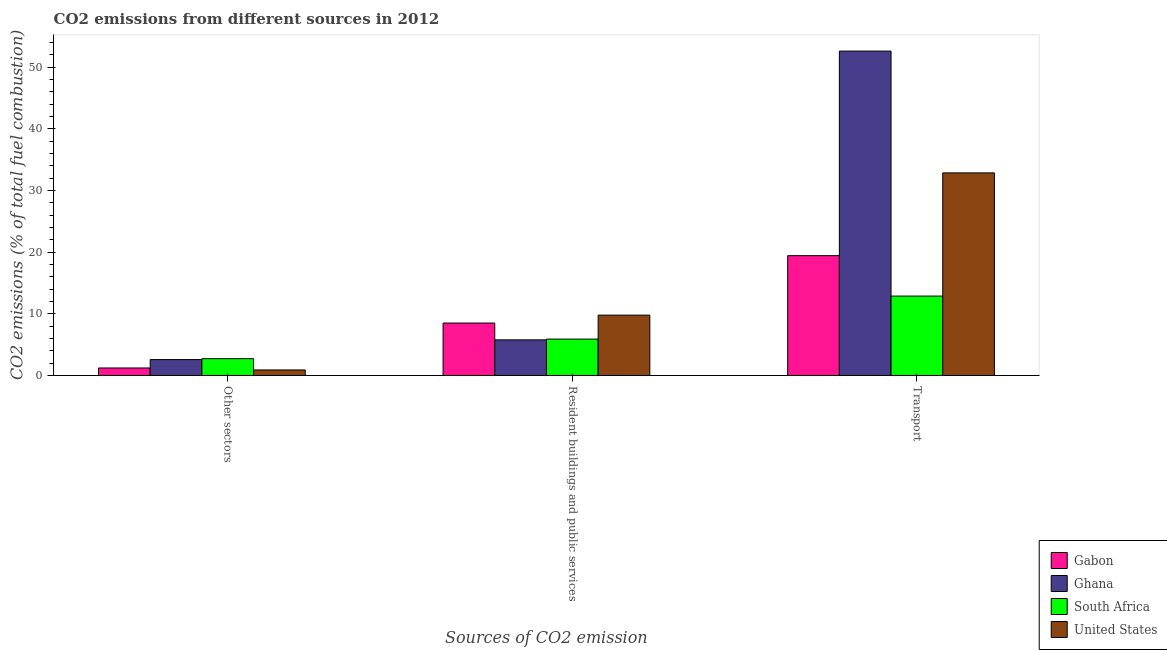How many groups of bars are there?
Your answer should be compact. 3. Are the number of bars per tick equal to the number of legend labels?
Offer a terse response. Yes. What is the label of the 3rd group of bars from the left?
Make the answer very short. Transport. What is the percentage of co2 emissions from transport in South Africa?
Provide a short and direct response. 12.88. Across all countries, what is the maximum percentage of co2 emissions from transport?
Make the answer very short. 52.62. Across all countries, what is the minimum percentage of co2 emissions from transport?
Provide a short and direct response. 12.88. What is the total percentage of co2 emissions from resident buildings and public services in the graph?
Your answer should be very brief. 29.96. What is the difference between the percentage of co2 emissions from transport in Gabon and that in Ghana?
Make the answer very short. -33.18. What is the difference between the percentage of co2 emissions from other sectors in Ghana and the percentage of co2 emissions from resident buildings and public services in United States?
Your answer should be very brief. -7.21. What is the average percentage of co2 emissions from transport per country?
Give a very brief answer. 29.45. What is the difference between the percentage of co2 emissions from other sectors and percentage of co2 emissions from resident buildings and public services in South Africa?
Offer a terse response. -3.17. In how many countries, is the percentage of co2 emissions from transport greater than 24 %?
Offer a very short reply. 2. What is the ratio of the percentage of co2 emissions from resident buildings and public services in South Africa to that in Gabon?
Your answer should be very brief. 0.69. Is the difference between the percentage of co2 emissions from transport in United States and Ghana greater than the difference between the percentage of co2 emissions from other sectors in United States and Ghana?
Provide a succinct answer. No. What is the difference between the highest and the second highest percentage of co2 emissions from other sectors?
Offer a terse response. 0.15. What is the difference between the highest and the lowest percentage of co2 emissions from other sectors?
Offer a terse response. 1.83. In how many countries, is the percentage of co2 emissions from transport greater than the average percentage of co2 emissions from transport taken over all countries?
Give a very brief answer. 2. Is the sum of the percentage of co2 emissions from other sectors in South Africa and United States greater than the maximum percentage of co2 emissions from transport across all countries?
Provide a succinct answer. No. What does the 1st bar from the left in Other sectors represents?
Provide a succinct answer. Gabon. What does the 2nd bar from the right in Transport represents?
Your answer should be compact. South Africa. Is it the case that in every country, the sum of the percentage of co2 emissions from other sectors and percentage of co2 emissions from resident buildings and public services is greater than the percentage of co2 emissions from transport?
Give a very brief answer. No. What is the difference between two consecutive major ticks on the Y-axis?
Provide a short and direct response. 10. Are the values on the major ticks of Y-axis written in scientific E-notation?
Offer a terse response. No. Does the graph contain grids?
Make the answer very short. No. Where does the legend appear in the graph?
Make the answer very short. Bottom right. How many legend labels are there?
Your answer should be compact. 4. What is the title of the graph?
Make the answer very short. CO2 emissions from different sources in 2012. Does "Ukraine" appear as one of the legend labels in the graph?
Give a very brief answer. No. What is the label or title of the X-axis?
Provide a short and direct response. Sources of CO2 emission. What is the label or title of the Y-axis?
Keep it short and to the point. CO2 emissions (% of total fuel combustion). What is the CO2 emissions (% of total fuel combustion) of Gabon in Other sectors?
Your response must be concise. 1.21. What is the CO2 emissions (% of total fuel combustion) of Ghana in Other sectors?
Your response must be concise. 2.58. What is the CO2 emissions (% of total fuel combustion) of South Africa in Other sectors?
Make the answer very short. 2.73. What is the CO2 emissions (% of total fuel combustion) in United States in Other sectors?
Your response must be concise. 0.89. What is the CO2 emissions (% of total fuel combustion) in Gabon in Resident buildings and public services?
Provide a succinct answer. 8.5. What is the CO2 emissions (% of total fuel combustion) in Ghana in Resident buildings and public services?
Offer a very short reply. 5.78. What is the CO2 emissions (% of total fuel combustion) of South Africa in Resident buildings and public services?
Make the answer very short. 5.9. What is the CO2 emissions (% of total fuel combustion) of United States in Resident buildings and public services?
Your response must be concise. 9.79. What is the CO2 emissions (% of total fuel combustion) of Gabon in Transport?
Give a very brief answer. 19.43. What is the CO2 emissions (% of total fuel combustion) of Ghana in Transport?
Your answer should be very brief. 52.62. What is the CO2 emissions (% of total fuel combustion) of South Africa in Transport?
Offer a very short reply. 12.88. What is the CO2 emissions (% of total fuel combustion) of United States in Transport?
Your response must be concise. 32.86. Across all Sources of CO2 emission, what is the maximum CO2 emissions (% of total fuel combustion) in Gabon?
Ensure brevity in your answer.  19.43. Across all Sources of CO2 emission, what is the maximum CO2 emissions (% of total fuel combustion) of Ghana?
Provide a short and direct response. 52.62. Across all Sources of CO2 emission, what is the maximum CO2 emissions (% of total fuel combustion) of South Africa?
Your answer should be compact. 12.88. Across all Sources of CO2 emission, what is the maximum CO2 emissions (% of total fuel combustion) in United States?
Your answer should be compact. 32.86. Across all Sources of CO2 emission, what is the minimum CO2 emissions (% of total fuel combustion) in Gabon?
Your answer should be very brief. 1.21. Across all Sources of CO2 emission, what is the minimum CO2 emissions (% of total fuel combustion) in Ghana?
Your response must be concise. 2.58. Across all Sources of CO2 emission, what is the minimum CO2 emissions (% of total fuel combustion) in South Africa?
Make the answer very short. 2.73. Across all Sources of CO2 emission, what is the minimum CO2 emissions (% of total fuel combustion) of United States?
Your response must be concise. 0.89. What is the total CO2 emissions (% of total fuel combustion) in Gabon in the graph?
Provide a short and direct response. 29.15. What is the total CO2 emissions (% of total fuel combustion) in Ghana in the graph?
Make the answer very short. 60.97. What is the total CO2 emissions (% of total fuel combustion) in South Africa in the graph?
Offer a very short reply. 21.51. What is the total CO2 emissions (% of total fuel combustion) of United States in the graph?
Your answer should be very brief. 43.54. What is the difference between the CO2 emissions (% of total fuel combustion) in Gabon in Other sectors and that in Resident buildings and public services?
Provide a succinct answer. -7.29. What is the difference between the CO2 emissions (% of total fuel combustion) in Ghana in Other sectors and that in Resident buildings and public services?
Provide a short and direct response. -3.2. What is the difference between the CO2 emissions (% of total fuel combustion) of South Africa in Other sectors and that in Resident buildings and public services?
Ensure brevity in your answer.  -3.17. What is the difference between the CO2 emissions (% of total fuel combustion) of United States in Other sectors and that in Resident buildings and public services?
Make the answer very short. -8.89. What is the difference between the CO2 emissions (% of total fuel combustion) of Gabon in Other sectors and that in Transport?
Make the answer very short. -18.22. What is the difference between the CO2 emissions (% of total fuel combustion) in Ghana in Other sectors and that in Transport?
Offer a terse response. -50.04. What is the difference between the CO2 emissions (% of total fuel combustion) in South Africa in Other sectors and that in Transport?
Your response must be concise. -10.15. What is the difference between the CO2 emissions (% of total fuel combustion) of United States in Other sectors and that in Transport?
Give a very brief answer. -31.96. What is the difference between the CO2 emissions (% of total fuel combustion) in Gabon in Resident buildings and public services and that in Transport?
Offer a terse response. -10.93. What is the difference between the CO2 emissions (% of total fuel combustion) in Ghana in Resident buildings and public services and that in Transport?
Your answer should be very brief. -46.84. What is the difference between the CO2 emissions (% of total fuel combustion) in South Africa in Resident buildings and public services and that in Transport?
Your response must be concise. -6.98. What is the difference between the CO2 emissions (% of total fuel combustion) in United States in Resident buildings and public services and that in Transport?
Ensure brevity in your answer.  -23.07. What is the difference between the CO2 emissions (% of total fuel combustion) in Gabon in Other sectors and the CO2 emissions (% of total fuel combustion) in Ghana in Resident buildings and public services?
Provide a short and direct response. -4.56. What is the difference between the CO2 emissions (% of total fuel combustion) in Gabon in Other sectors and the CO2 emissions (% of total fuel combustion) in South Africa in Resident buildings and public services?
Give a very brief answer. -4.69. What is the difference between the CO2 emissions (% of total fuel combustion) in Gabon in Other sectors and the CO2 emissions (% of total fuel combustion) in United States in Resident buildings and public services?
Give a very brief answer. -8.57. What is the difference between the CO2 emissions (% of total fuel combustion) of Ghana in Other sectors and the CO2 emissions (% of total fuel combustion) of South Africa in Resident buildings and public services?
Your answer should be very brief. -3.32. What is the difference between the CO2 emissions (% of total fuel combustion) in Ghana in Other sectors and the CO2 emissions (% of total fuel combustion) in United States in Resident buildings and public services?
Give a very brief answer. -7.21. What is the difference between the CO2 emissions (% of total fuel combustion) in South Africa in Other sectors and the CO2 emissions (% of total fuel combustion) in United States in Resident buildings and public services?
Keep it short and to the point. -7.06. What is the difference between the CO2 emissions (% of total fuel combustion) in Gabon in Other sectors and the CO2 emissions (% of total fuel combustion) in Ghana in Transport?
Your answer should be very brief. -51.4. What is the difference between the CO2 emissions (% of total fuel combustion) of Gabon in Other sectors and the CO2 emissions (% of total fuel combustion) of South Africa in Transport?
Offer a very short reply. -11.66. What is the difference between the CO2 emissions (% of total fuel combustion) of Gabon in Other sectors and the CO2 emissions (% of total fuel combustion) of United States in Transport?
Provide a succinct answer. -31.64. What is the difference between the CO2 emissions (% of total fuel combustion) in Ghana in Other sectors and the CO2 emissions (% of total fuel combustion) in South Africa in Transport?
Keep it short and to the point. -10.3. What is the difference between the CO2 emissions (% of total fuel combustion) of Ghana in Other sectors and the CO2 emissions (% of total fuel combustion) of United States in Transport?
Make the answer very short. -30.28. What is the difference between the CO2 emissions (% of total fuel combustion) in South Africa in Other sectors and the CO2 emissions (% of total fuel combustion) in United States in Transport?
Your response must be concise. -30.13. What is the difference between the CO2 emissions (% of total fuel combustion) in Gabon in Resident buildings and public services and the CO2 emissions (% of total fuel combustion) in Ghana in Transport?
Make the answer very short. -44.11. What is the difference between the CO2 emissions (% of total fuel combustion) in Gabon in Resident buildings and public services and the CO2 emissions (% of total fuel combustion) in South Africa in Transport?
Your answer should be compact. -4.38. What is the difference between the CO2 emissions (% of total fuel combustion) in Gabon in Resident buildings and public services and the CO2 emissions (% of total fuel combustion) in United States in Transport?
Ensure brevity in your answer.  -24.36. What is the difference between the CO2 emissions (% of total fuel combustion) in Ghana in Resident buildings and public services and the CO2 emissions (% of total fuel combustion) in South Africa in Transport?
Provide a succinct answer. -7.1. What is the difference between the CO2 emissions (% of total fuel combustion) of Ghana in Resident buildings and public services and the CO2 emissions (% of total fuel combustion) of United States in Transport?
Give a very brief answer. -27.08. What is the difference between the CO2 emissions (% of total fuel combustion) of South Africa in Resident buildings and public services and the CO2 emissions (% of total fuel combustion) of United States in Transport?
Give a very brief answer. -26.96. What is the average CO2 emissions (% of total fuel combustion) of Gabon per Sources of CO2 emission?
Provide a short and direct response. 9.72. What is the average CO2 emissions (% of total fuel combustion) in Ghana per Sources of CO2 emission?
Offer a very short reply. 20.32. What is the average CO2 emissions (% of total fuel combustion) of South Africa per Sources of CO2 emission?
Your answer should be compact. 7.17. What is the average CO2 emissions (% of total fuel combustion) in United States per Sources of CO2 emission?
Provide a short and direct response. 14.51. What is the difference between the CO2 emissions (% of total fuel combustion) of Gabon and CO2 emissions (% of total fuel combustion) of Ghana in Other sectors?
Ensure brevity in your answer.  -1.36. What is the difference between the CO2 emissions (% of total fuel combustion) in Gabon and CO2 emissions (% of total fuel combustion) in South Africa in Other sectors?
Keep it short and to the point. -1.51. What is the difference between the CO2 emissions (% of total fuel combustion) of Gabon and CO2 emissions (% of total fuel combustion) of United States in Other sectors?
Keep it short and to the point. 0.32. What is the difference between the CO2 emissions (% of total fuel combustion) in Ghana and CO2 emissions (% of total fuel combustion) in South Africa in Other sectors?
Offer a very short reply. -0.15. What is the difference between the CO2 emissions (% of total fuel combustion) in Ghana and CO2 emissions (% of total fuel combustion) in United States in Other sectors?
Provide a short and direct response. 1.68. What is the difference between the CO2 emissions (% of total fuel combustion) of South Africa and CO2 emissions (% of total fuel combustion) of United States in Other sectors?
Provide a succinct answer. 1.83. What is the difference between the CO2 emissions (% of total fuel combustion) of Gabon and CO2 emissions (% of total fuel combustion) of Ghana in Resident buildings and public services?
Your answer should be compact. 2.73. What is the difference between the CO2 emissions (% of total fuel combustion) of Gabon and CO2 emissions (% of total fuel combustion) of South Africa in Resident buildings and public services?
Your answer should be compact. 2.6. What is the difference between the CO2 emissions (% of total fuel combustion) of Gabon and CO2 emissions (% of total fuel combustion) of United States in Resident buildings and public services?
Provide a short and direct response. -1.28. What is the difference between the CO2 emissions (% of total fuel combustion) of Ghana and CO2 emissions (% of total fuel combustion) of South Africa in Resident buildings and public services?
Your answer should be compact. -0.12. What is the difference between the CO2 emissions (% of total fuel combustion) of Ghana and CO2 emissions (% of total fuel combustion) of United States in Resident buildings and public services?
Your answer should be compact. -4.01. What is the difference between the CO2 emissions (% of total fuel combustion) of South Africa and CO2 emissions (% of total fuel combustion) of United States in Resident buildings and public services?
Your answer should be very brief. -3.89. What is the difference between the CO2 emissions (% of total fuel combustion) of Gabon and CO2 emissions (% of total fuel combustion) of Ghana in Transport?
Your response must be concise. -33.18. What is the difference between the CO2 emissions (% of total fuel combustion) in Gabon and CO2 emissions (% of total fuel combustion) in South Africa in Transport?
Your response must be concise. 6.55. What is the difference between the CO2 emissions (% of total fuel combustion) in Gabon and CO2 emissions (% of total fuel combustion) in United States in Transport?
Provide a short and direct response. -13.42. What is the difference between the CO2 emissions (% of total fuel combustion) of Ghana and CO2 emissions (% of total fuel combustion) of South Africa in Transport?
Your answer should be compact. 39.74. What is the difference between the CO2 emissions (% of total fuel combustion) in Ghana and CO2 emissions (% of total fuel combustion) in United States in Transport?
Provide a short and direct response. 19.76. What is the difference between the CO2 emissions (% of total fuel combustion) in South Africa and CO2 emissions (% of total fuel combustion) in United States in Transport?
Give a very brief answer. -19.98. What is the ratio of the CO2 emissions (% of total fuel combustion) of Gabon in Other sectors to that in Resident buildings and public services?
Offer a very short reply. 0.14. What is the ratio of the CO2 emissions (% of total fuel combustion) of Ghana in Other sectors to that in Resident buildings and public services?
Provide a succinct answer. 0.45. What is the ratio of the CO2 emissions (% of total fuel combustion) in South Africa in Other sectors to that in Resident buildings and public services?
Provide a short and direct response. 0.46. What is the ratio of the CO2 emissions (% of total fuel combustion) of United States in Other sectors to that in Resident buildings and public services?
Your answer should be very brief. 0.09. What is the ratio of the CO2 emissions (% of total fuel combustion) of Gabon in Other sectors to that in Transport?
Your answer should be compact. 0.06. What is the ratio of the CO2 emissions (% of total fuel combustion) of Ghana in Other sectors to that in Transport?
Offer a terse response. 0.05. What is the ratio of the CO2 emissions (% of total fuel combustion) in South Africa in Other sectors to that in Transport?
Provide a succinct answer. 0.21. What is the ratio of the CO2 emissions (% of total fuel combustion) in United States in Other sectors to that in Transport?
Give a very brief answer. 0.03. What is the ratio of the CO2 emissions (% of total fuel combustion) of Gabon in Resident buildings and public services to that in Transport?
Offer a very short reply. 0.44. What is the ratio of the CO2 emissions (% of total fuel combustion) in Ghana in Resident buildings and public services to that in Transport?
Ensure brevity in your answer.  0.11. What is the ratio of the CO2 emissions (% of total fuel combustion) of South Africa in Resident buildings and public services to that in Transport?
Offer a very short reply. 0.46. What is the ratio of the CO2 emissions (% of total fuel combustion) of United States in Resident buildings and public services to that in Transport?
Your response must be concise. 0.3. What is the difference between the highest and the second highest CO2 emissions (% of total fuel combustion) in Gabon?
Provide a succinct answer. 10.93. What is the difference between the highest and the second highest CO2 emissions (% of total fuel combustion) of Ghana?
Keep it short and to the point. 46.84. What is the difference between the highest and the second highest CO2 emissions (% of total fuel combustion) of South Africa?
Your answer should be compact. 6.98. What is the difference between the highest and the second highest CO2 emissions (% of total fuel combustion) in United States?
Your answer should be compact. 23.07. What is the difference between the highest and the lowest CO2 emissions (% of total fuel combustion) of Gabon?
Your answer should be compact. 18.22. What is the difference between the highest and the lowest CO2 emissions (% of total fuel combustion) in Ghana?
Your response must be concise. 50.04. What is the difference between the highest and the lowest CO2 emissions (% of total fuel combustion) in South Africa?
Your answer should be very brief. 10.15. What is the difference between the highest and the lowest CO2 emissions (% of total fuel combustion) of United States?
Keep it short and to the point. 31.96. 